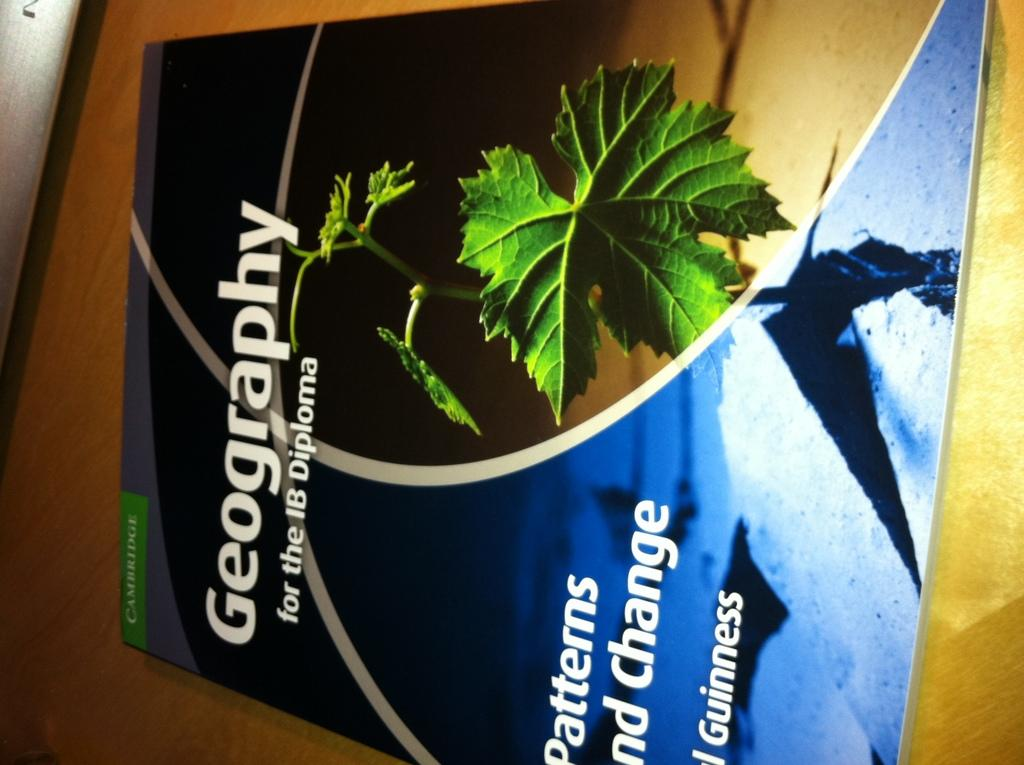<image>
Relay a brief, clear account of the picture shown. A textbook with the title Geography for the IB Diploma. 